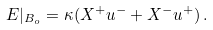Convert formula to latex. <formula><loc_0><loc_0><loc_500><loc_500>E | _ { B _ { o } } = \kappa ( X ^ { + } u ^ { - } + X ^ { - } u ^ { + } ) { \, } .</formula> 